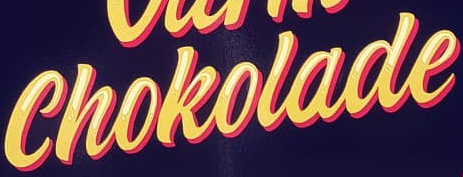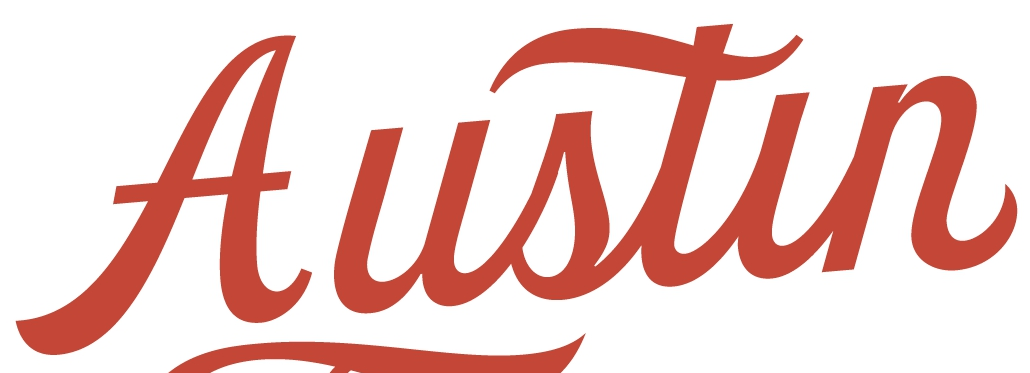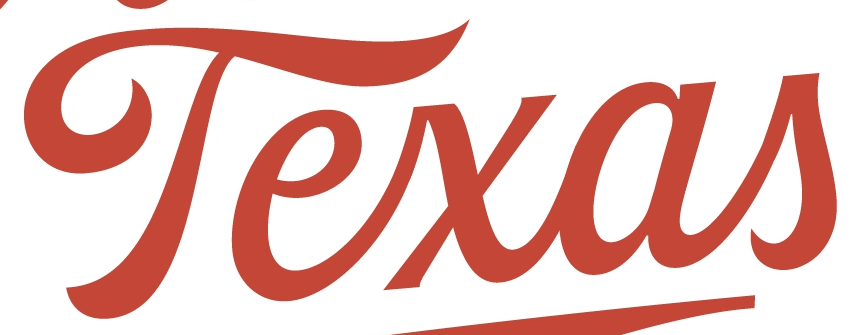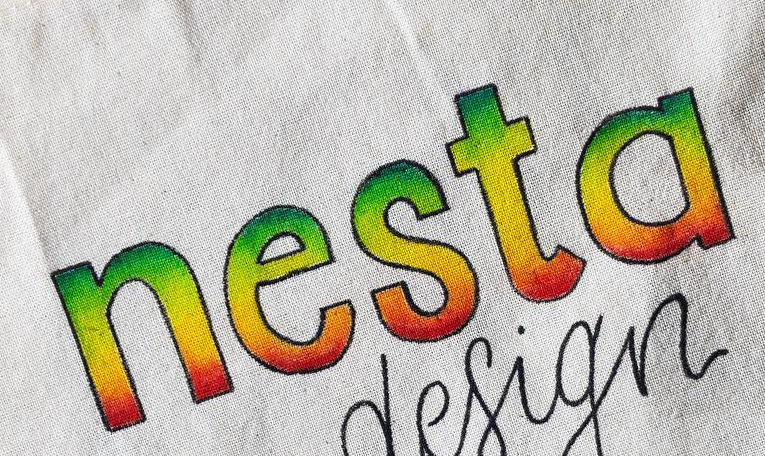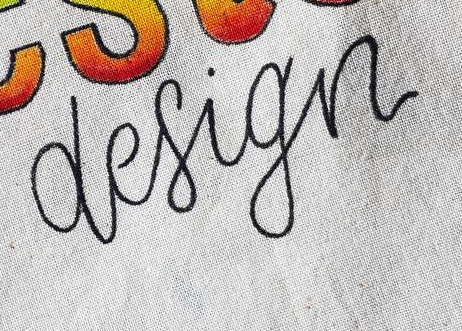Identify the words shown in these images in order, separated by a semicolon. Chokolade; Austin; Texas; nesta; design 